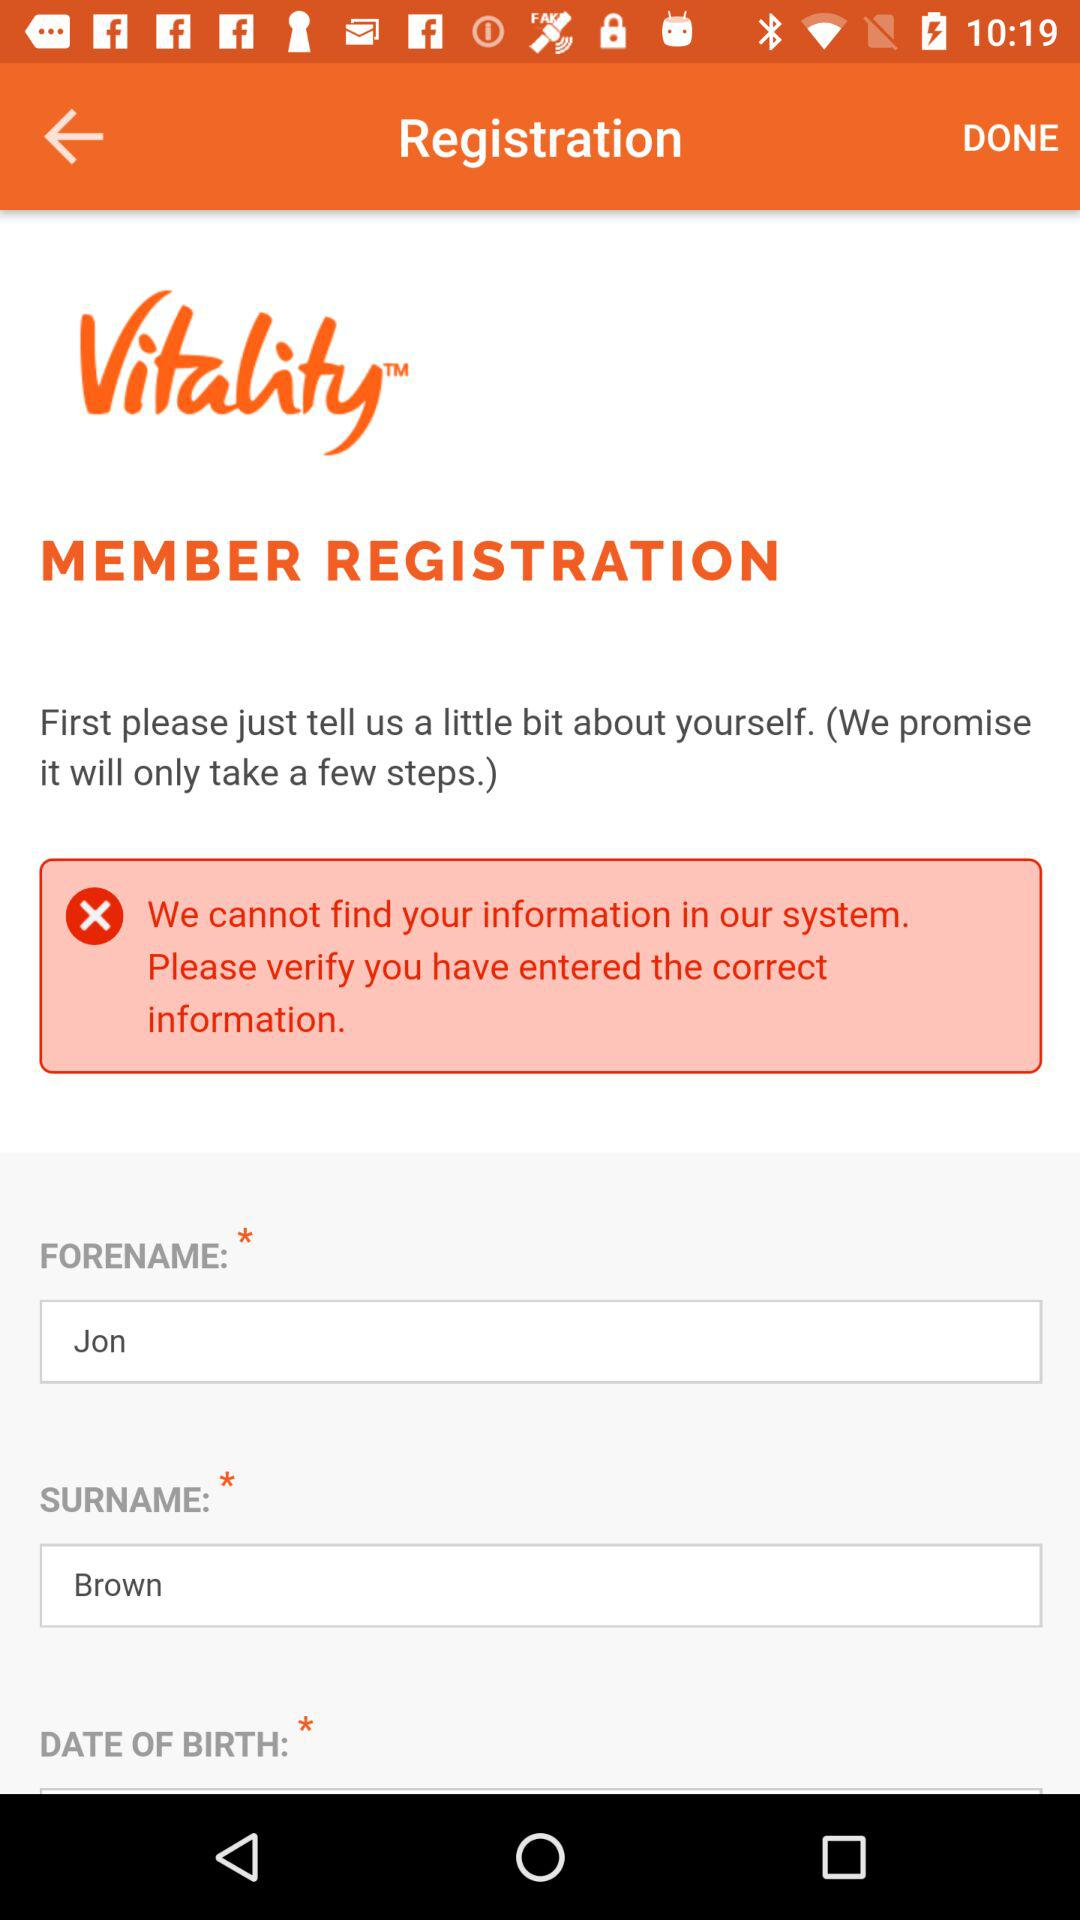What is the app name? The app name is "Vitality". 